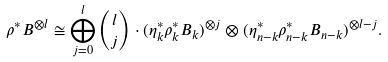Convert formula to latex. <formula><loc_0><loc_0><loc_500><loc_500>\rho ^ { * } B ^ { \otimes l } \cong \bigoplus _ { j = 0 } ^ { l } \binom { l } { j } \cdot ( \eta _ { k } ^ { * } \rho _ { k } ^ { * } B _ { k } ) ^ { \otimes j } \otimes ( \eta _ { n - k } ^ { * } \rho _ { n - k } ^ { * } B _ { n - k } ) ^ { \otimes l - j } .</formula> 